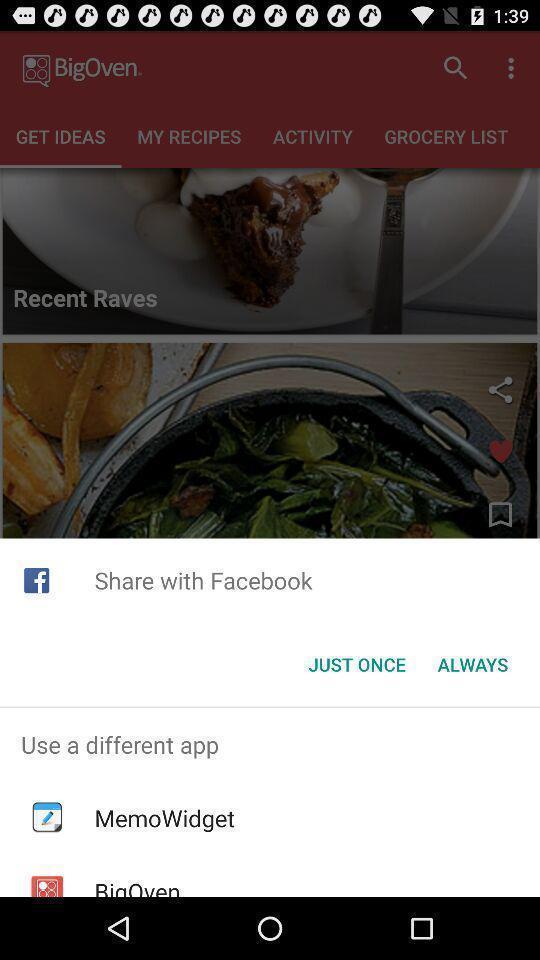Please provide a description for this image. Pop up page for sharing through different apps. 